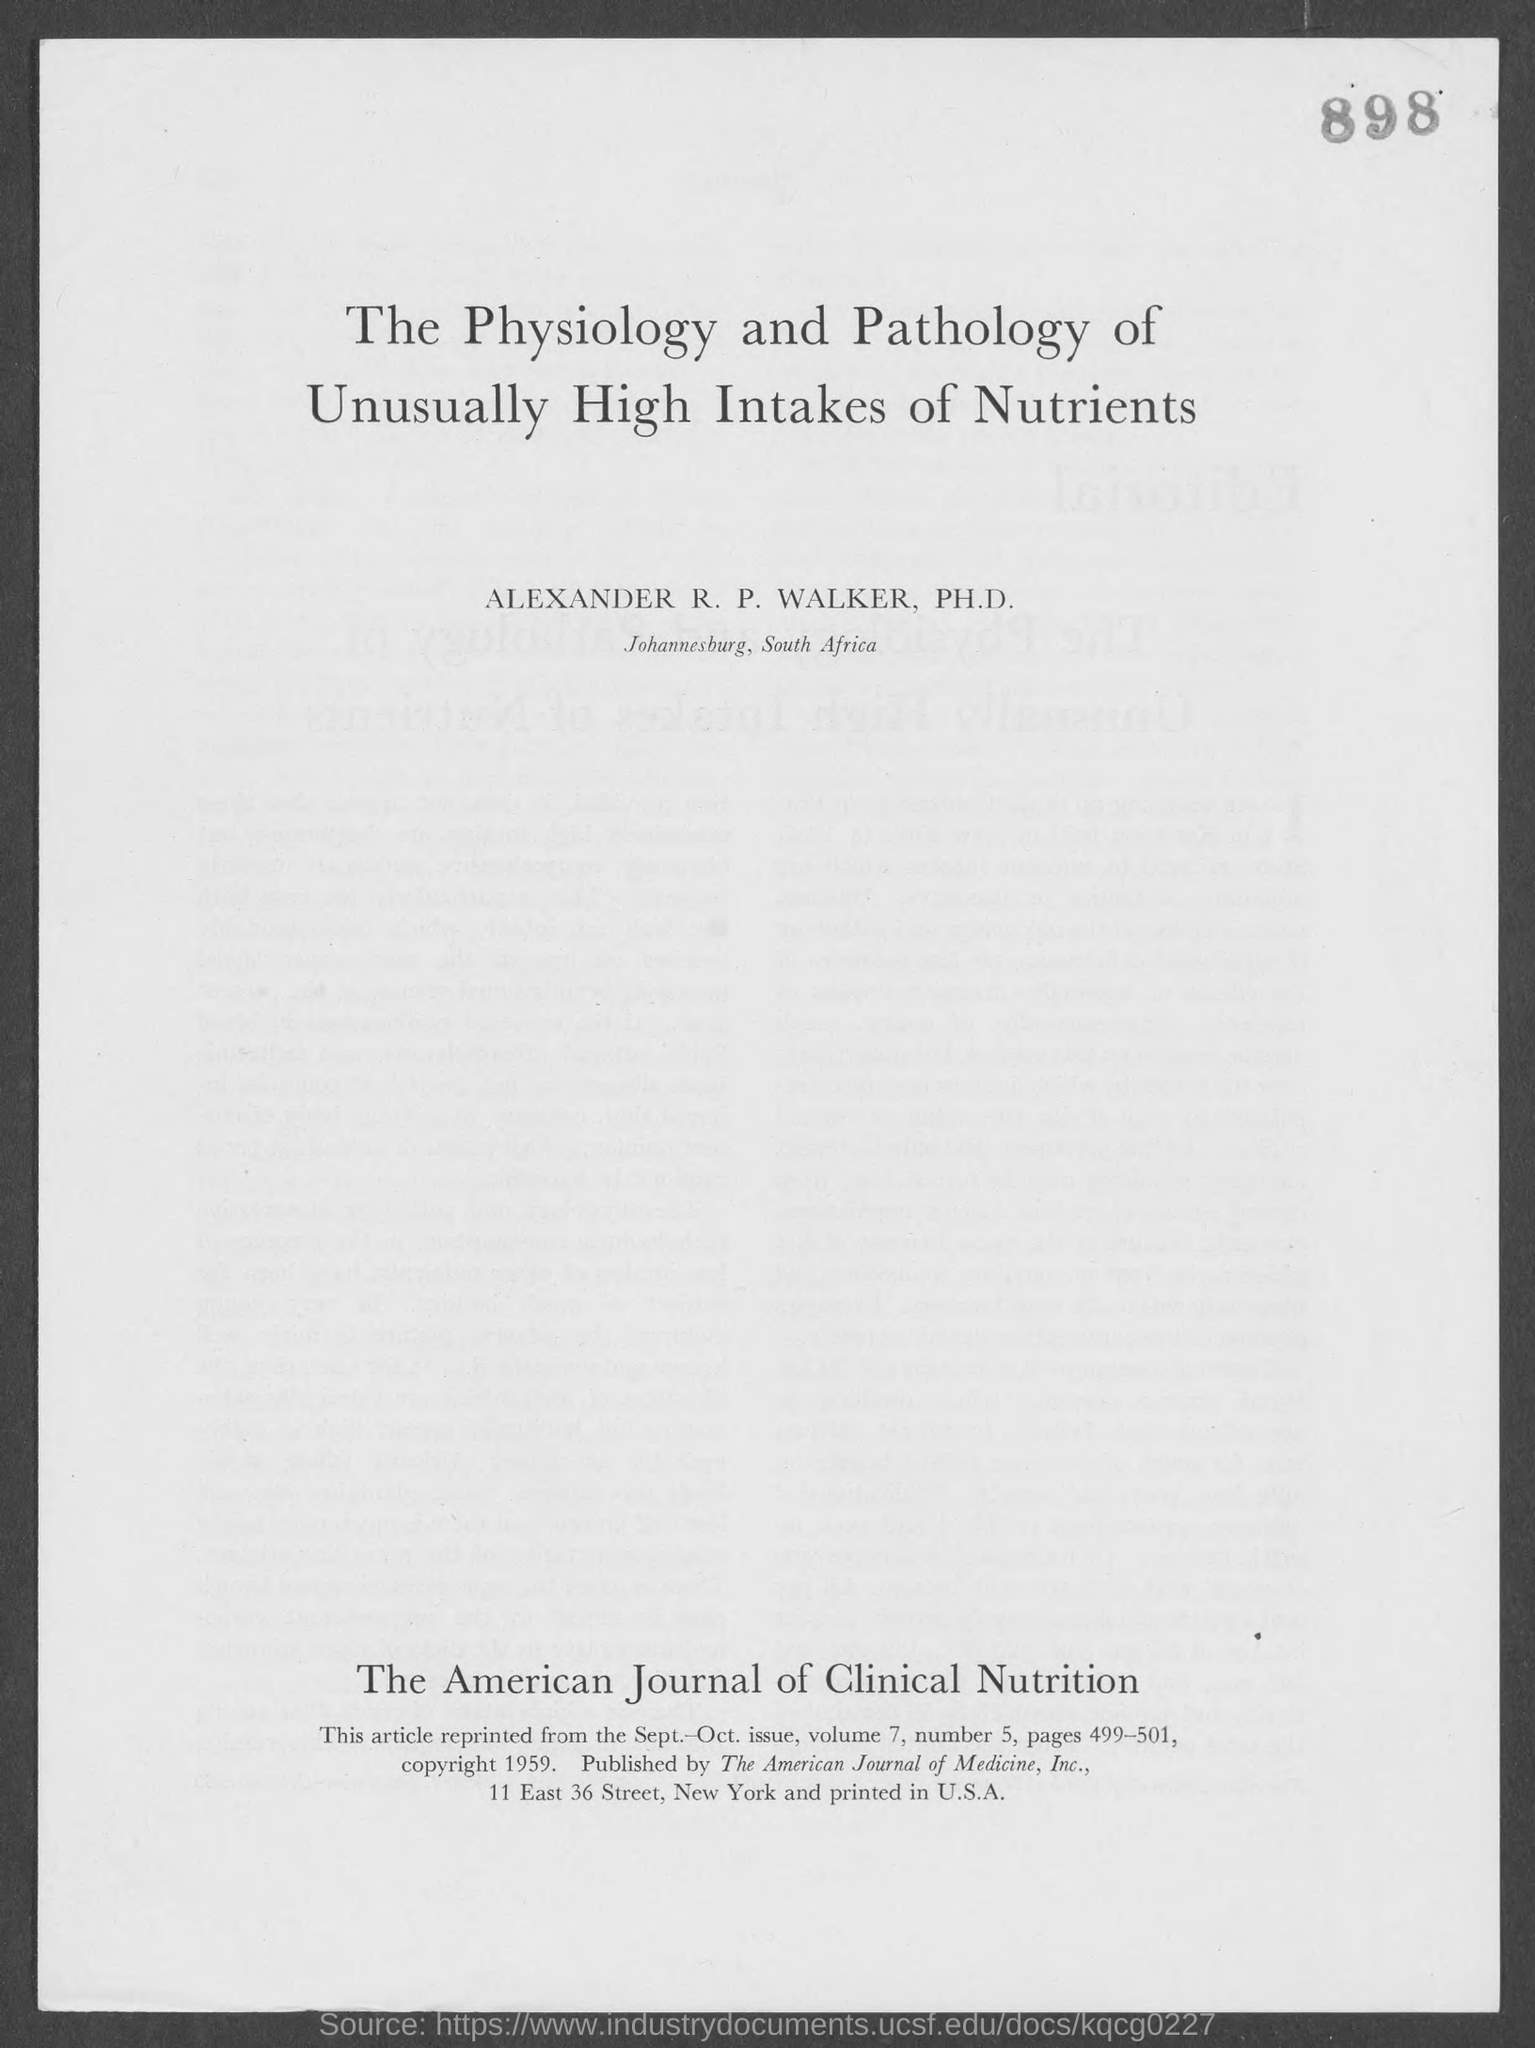This article is reprinted from which issue?
Keep it short and to the point. Sept. - Oct. issue. What is the Volume?
Provide a succinct answer. 7. What is the Number?
Provide a succinct answer. 5. What are the pages?
Ensure brevity in your answer.  499-501. 